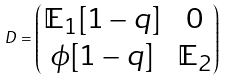Convert formula to latex. <formula><loc_0><loc_0><loc_500><loc_500>D = \begin{pmatrix} \mathbb { E } _ { 1 } [ 1 - q ] & 0 \\ \phi [ 1 - q ] & \mathbb { E } _ { 2 } \end{pmatrix}</formula> 